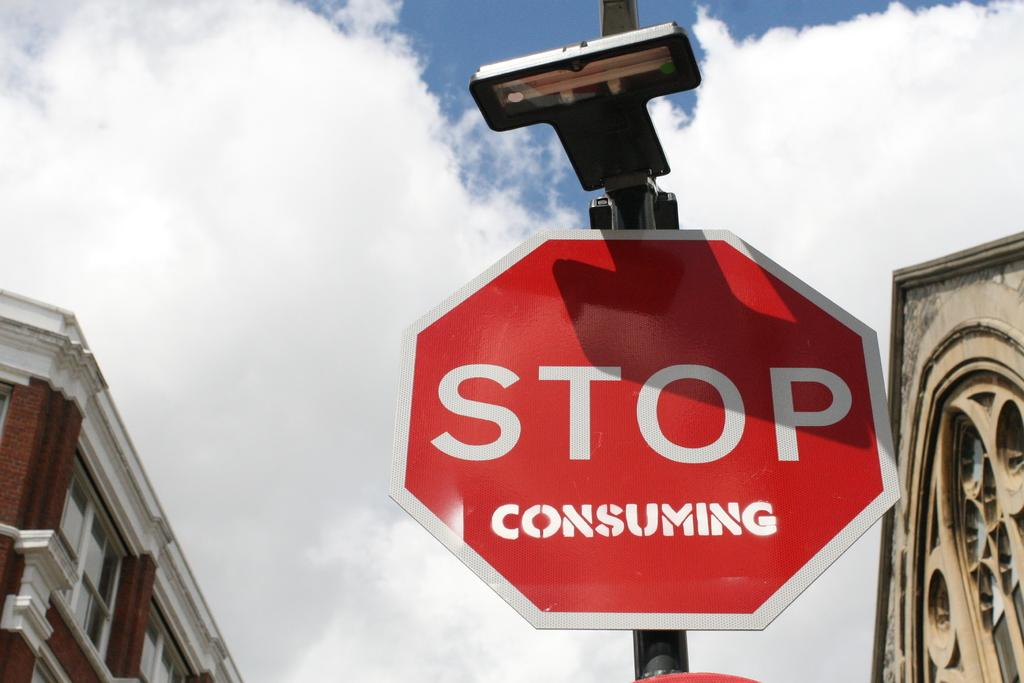<image>
Present a compact description of the photo's key features. A stop sign has been altered to say "stop consuming." 